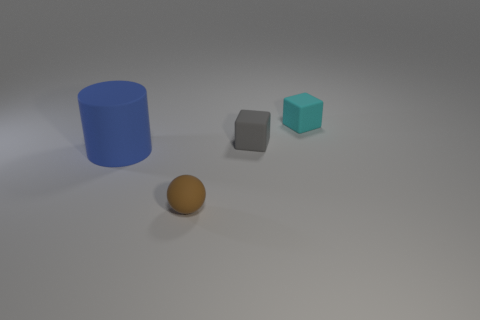Add 4 blue rubber cylinders. How many objects exist? 8 Subtract all balls. How many objects are left? 3 Add 4 brown things. How many brown things exist? 5 Subtract 0 yellow cylinders. How many objects are left? 4 Subtract all tiny green shiny cylinders. Subtract all gray objects. How many objects are left? 3 Add 4 small things. How many small things are left? 7 